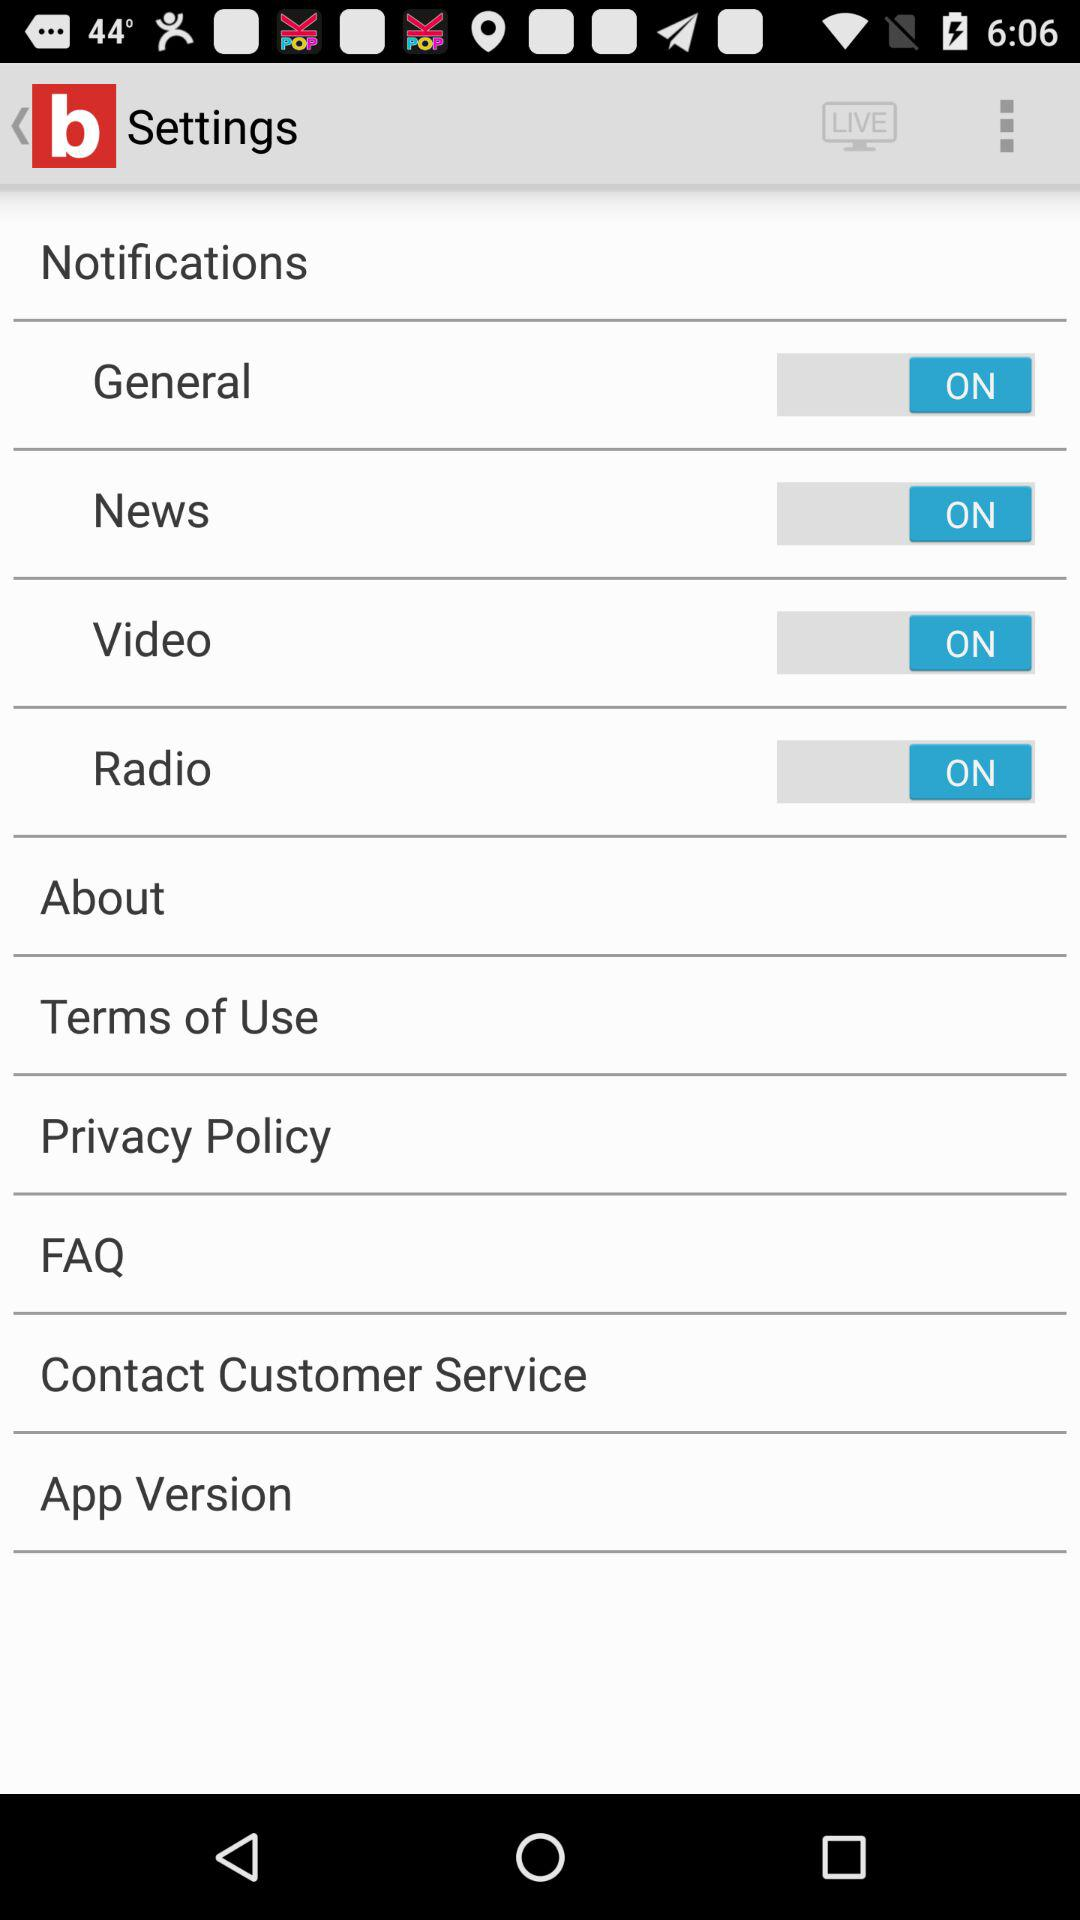What is the status of "Radio"? The status is "on". 